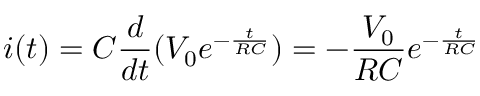<formula> <loc_0><loc_0><loc_500><loc_500>i ( t ) = C \frac { d } { d t } ( V _ { 0 } e ^ { - \frac { t } { R C } } ) = - \frac { V _ { 0 } } { R C } e ^ { - \frac { t } { R C } }</formula> 